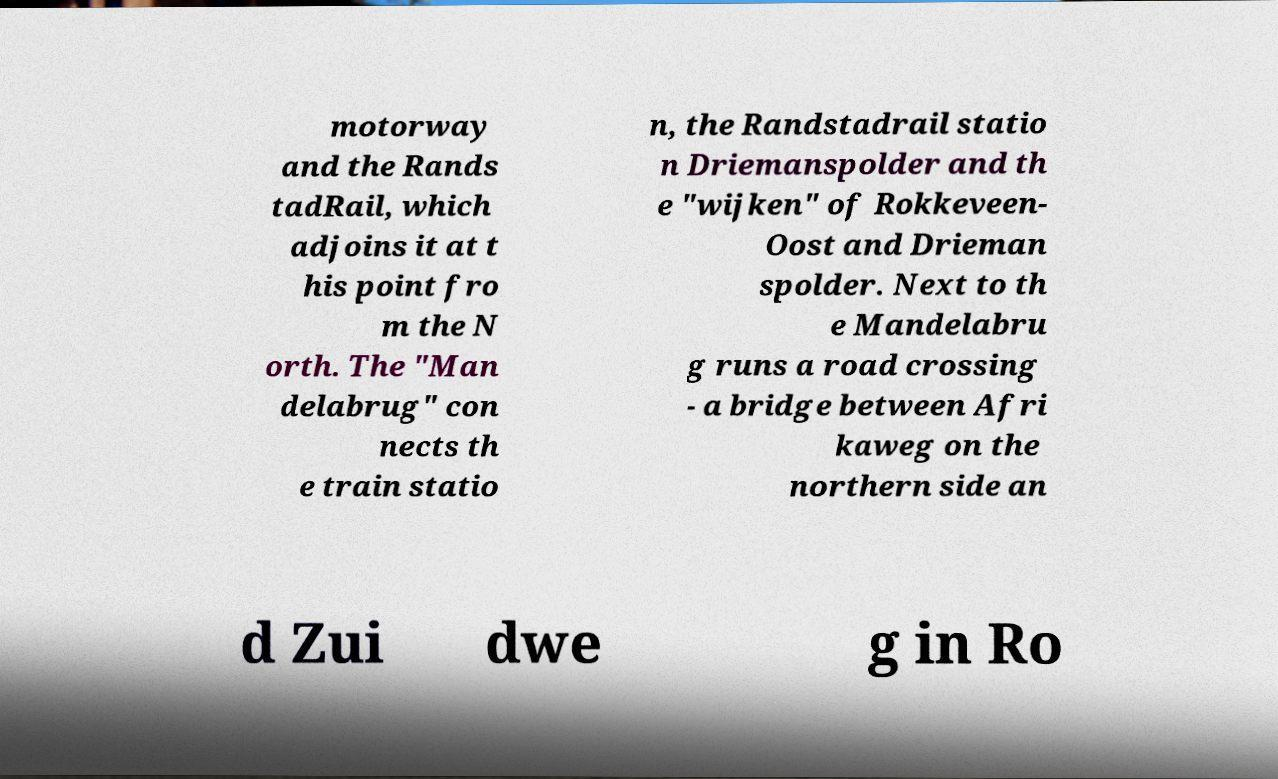Can you accurately transcribe the text from the provided image for me? motorway and the Rands tadRail, which adjoins it at t his point fro m the N orth. The "Man delabrug" con nects th e train statio n, the Randstadrail statio n Driemanspolder and th e "wijken" of Rokkeveen- Oost and Drieman spolder. Next to th e Mandelabru g runs a road crossing - a bridge between Afri kaweg on the northern side an d Zui dwe g in Ro 